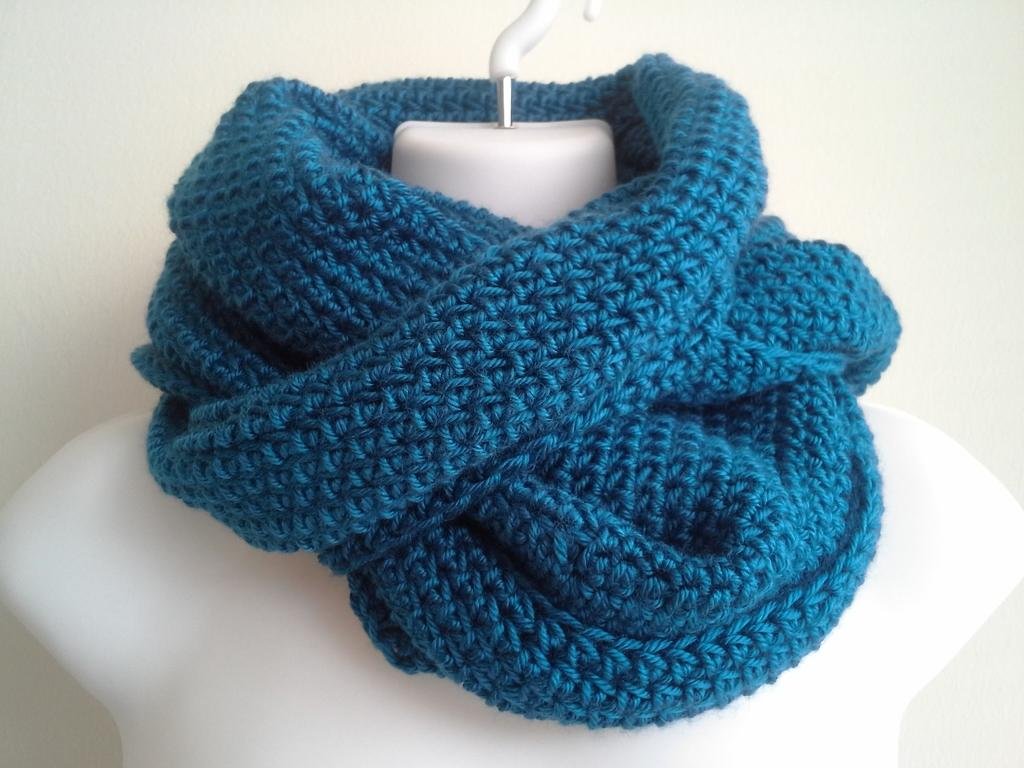What is the main subject of the image? There is a white color mannequin in the image. What is covering the mannequin? There is a blue color woolen cloth on the mannequin. What can be seen in the background of the image? There is a white wall in the background of the image. Can you see any boats in the harbor in the image? There is no harbor or boats present in the image; it features a mannequin with a woolen cloth and a white wall in the background. 